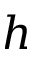Convert formula to latex. <formula><loc_0><loc_0><loc_500><loc_500>h</formula> 